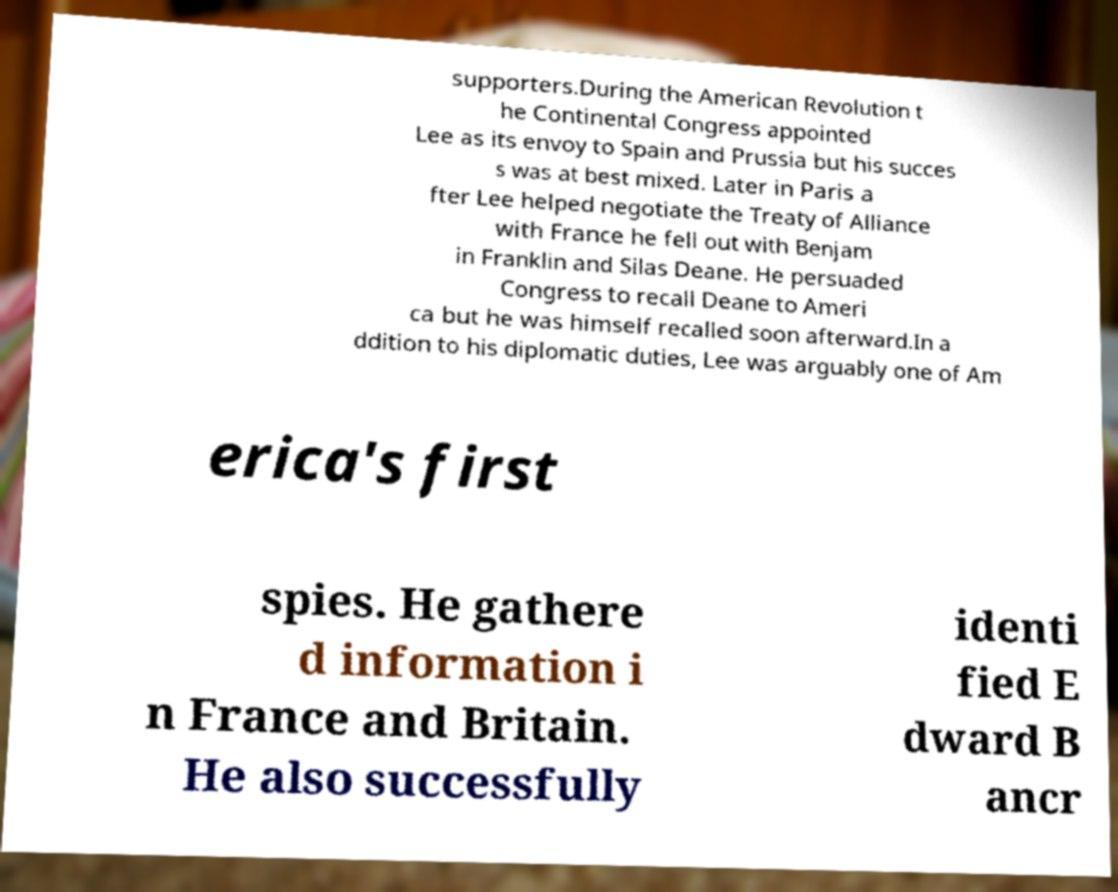Can you read and provide the text displayed in the image?This photo seems to have some interesting text. Can you extract and type it out for me? supporters.During the American Revolution t he Continental Congress appointed Lee as its envoy to Spain and Prussia but his succes s was at best mixed. Later in Paris a fter Lee helped negotiate the Treaty of Alliance with France he fell out with Benjam in Franklin and Silas Deane. He persuaded Congress to recall Deane to Ameri ca but he was himself recalled soon afterward.In a ddition to his diplomatic duties, Lee was arguably one of Am erica's first spies. He gathere d information i n France and Britain. He also successfully identi fied E dward B ancr 